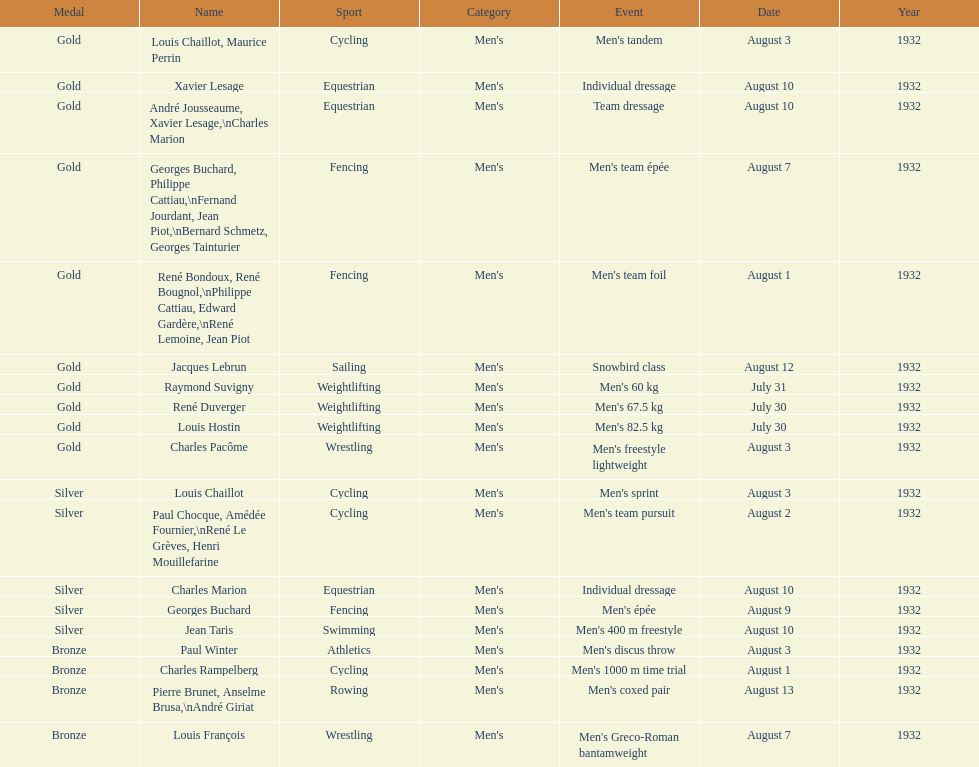How many total gold medals were won by weightlifting? 3. 